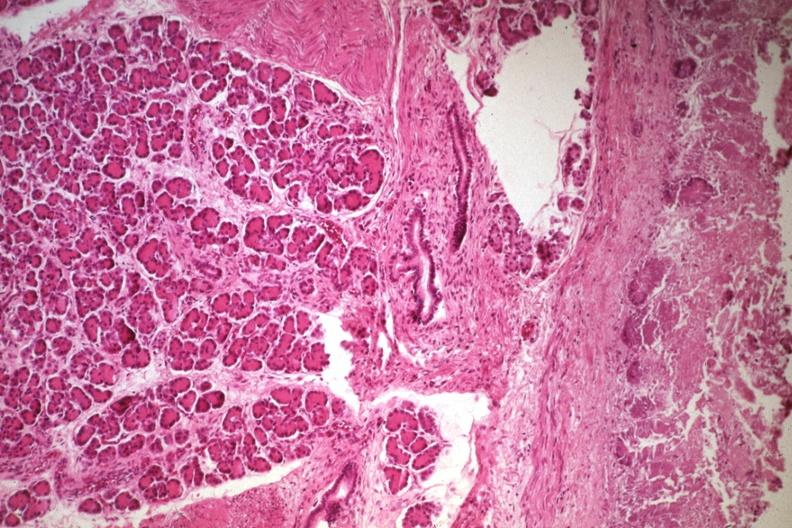does this image show not the best photo but a good illustration of lesion?
Answer the question using a single word or phrase. Yes 